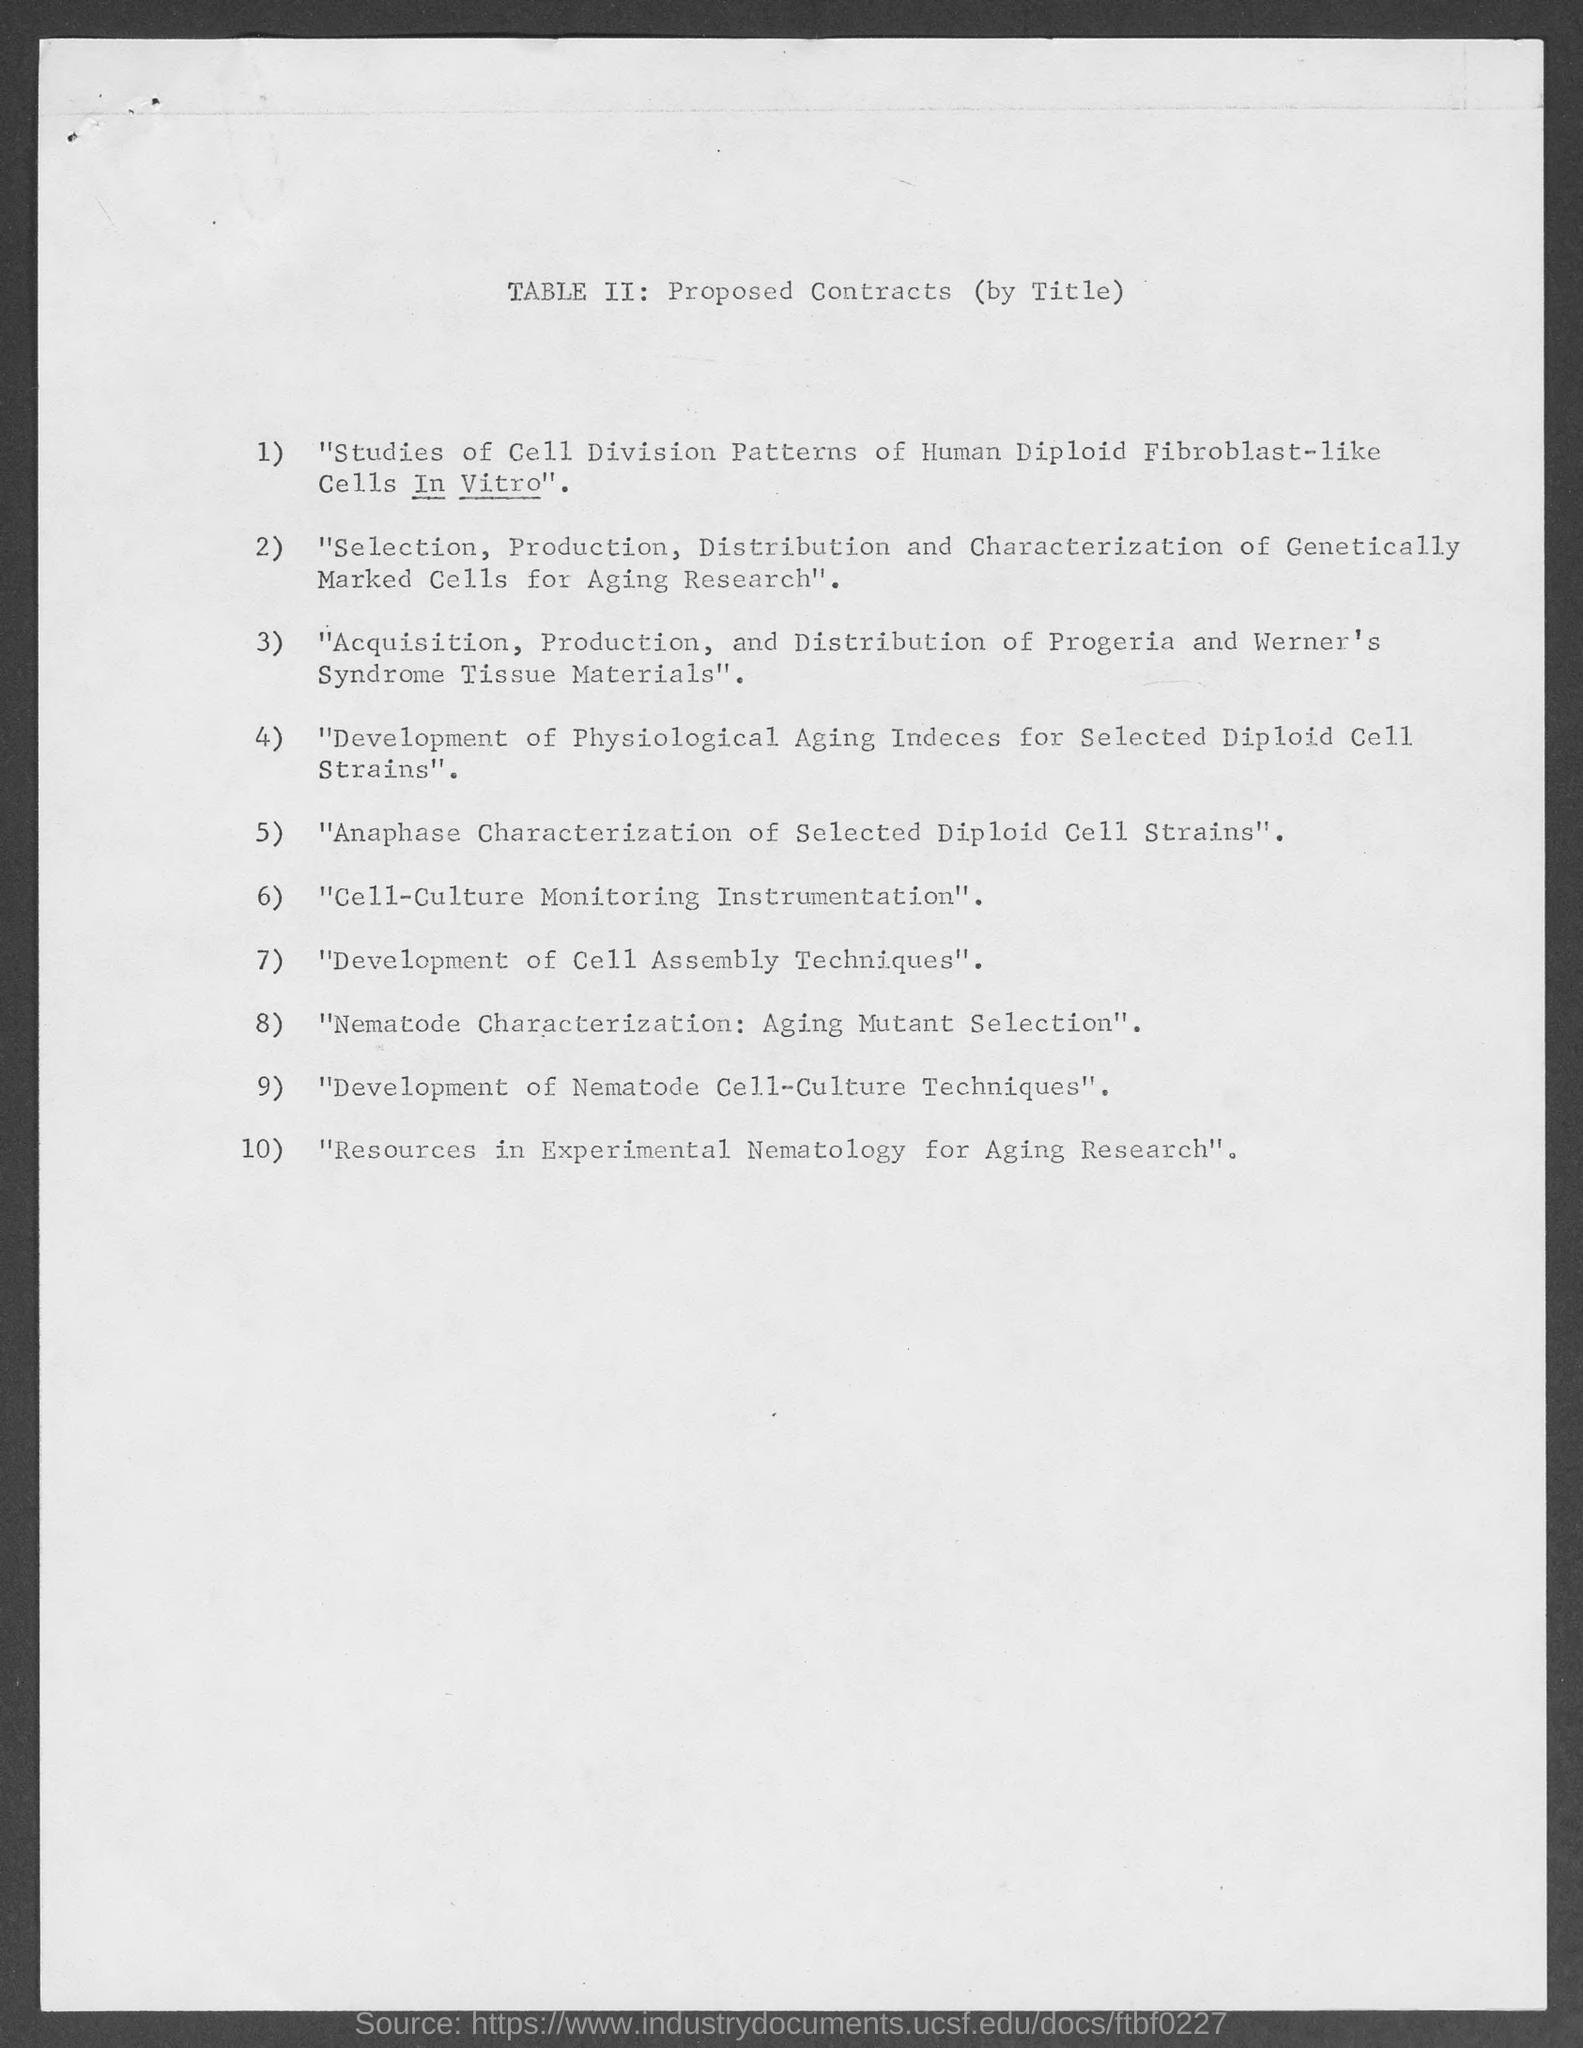Highlight a few significant elements in this photo. This document is titled TABLE II: Proposed Contracts (by Title). 